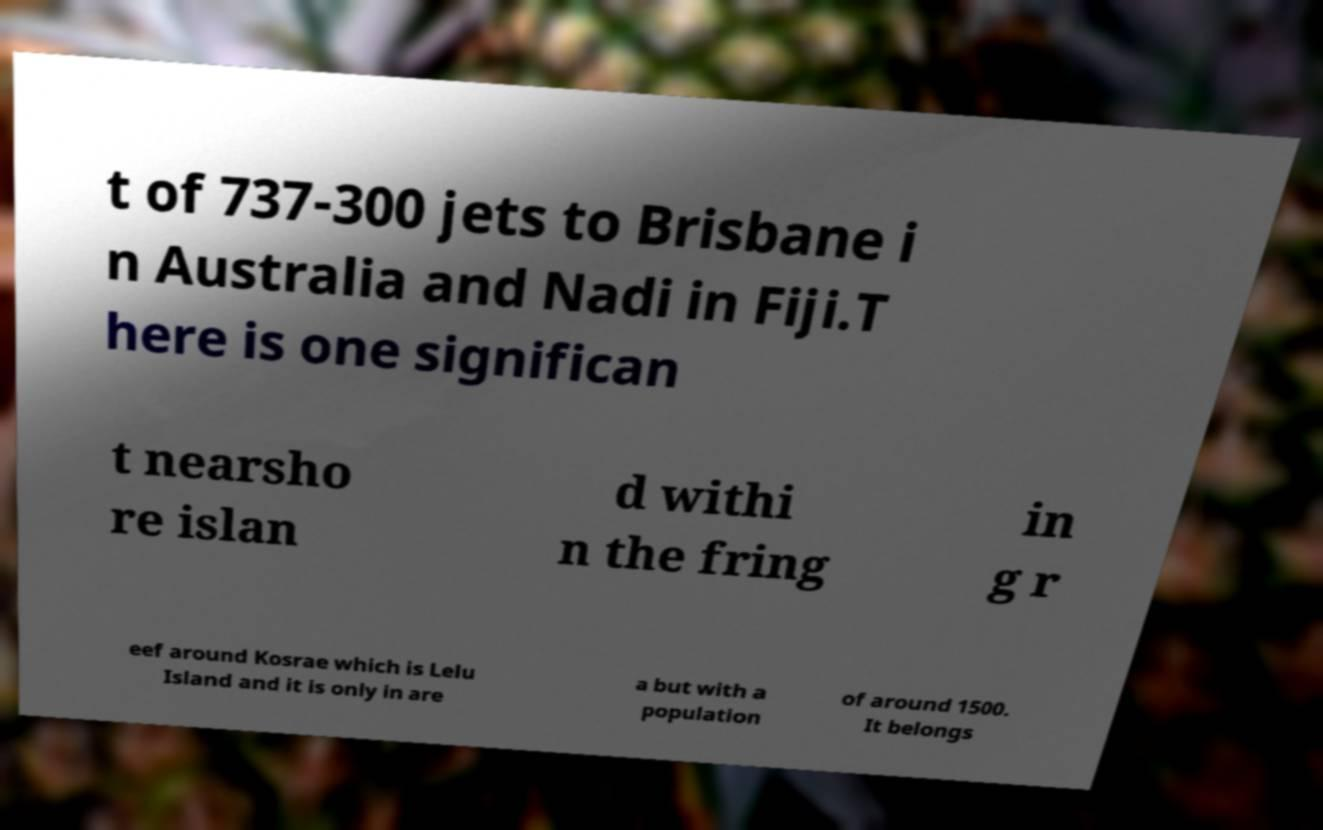What messages or text are displayed in this image? I need them in a readable, typed format. t of 737-300 jets to Brisbane i n Australia and Nadi in Fiji.T here is one significan t nearsho re islan d withi n the fring in g r eef around Kosrae which is Lelu Island and it is only in are a but with a population of around 1500. It belongs 